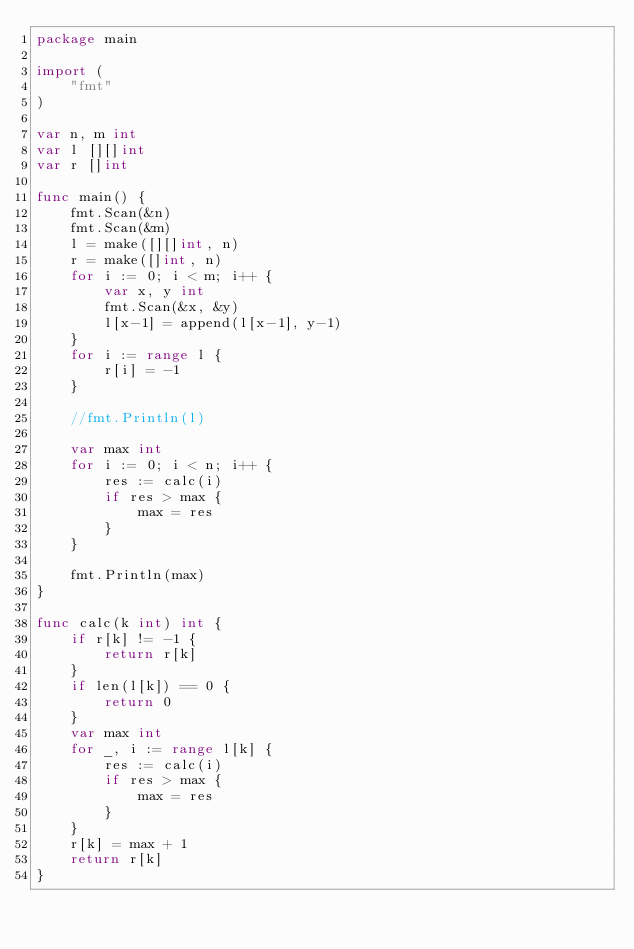Convert code to text. <code><loc_0><loc_0><loc_500><loc_500><_Go_>package main

import (
    "fmt"
)

var n, m int 
var l [][]int
var r []int

func main() {
    fmt.Scan(&n)
    fmt.Scan(&m)
    l = make([][]int, n)
    r = make([]int, n)
    for i := 0; i < m; i++ {
        var x, y int 
        fmt.Scan(&x, &y) 
        l[x-1] = append(l[x-1], y-1)
    }   
    for i := range l { 
        r[i] = -1
    }   

    //fmt.Println(l)

    var max int 
    for i := 0; i < n; i++ {
        res := calc(i)
        if res > max {
            max = res 
        }   
    }   

    fmt.Println(max)
}

func calc(k int) int {
    if r[k] != -1 {
        return r[k]
    }   
    if len(l[k]) == 0 { 
        return 0
    }   
    var max int 
    for _, i := range l[k] {
        res := calc(i)
        if res > max {
            max = res 
        }   
    }   
    r[k] = max + 1 
    return r[k]
}
</code> 